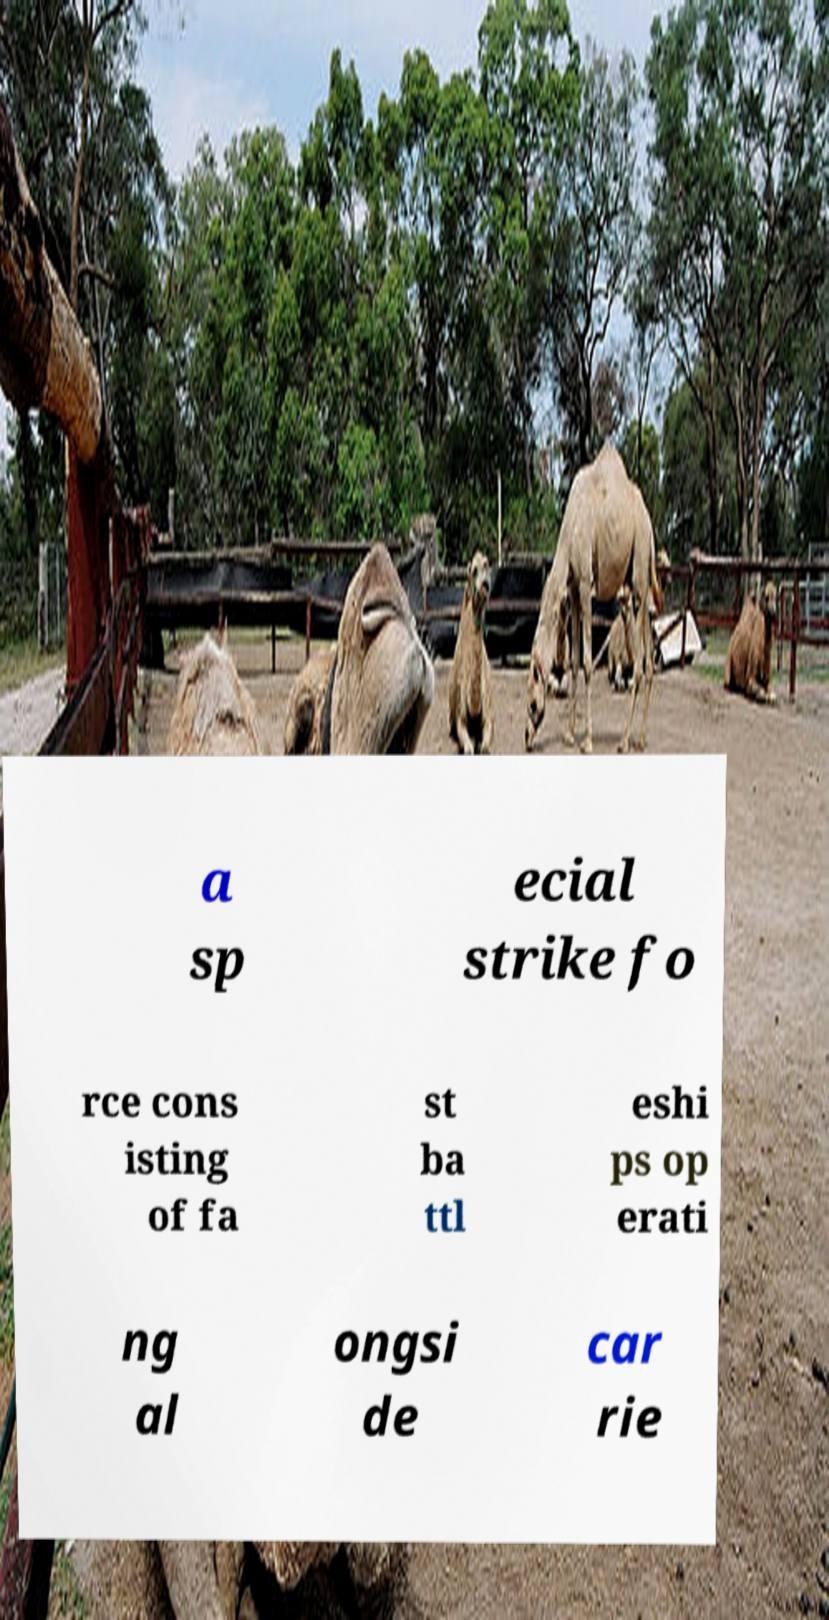For documentation purposes, I need the text within this image transcribed. Could you provide that? a sp ecial strike fo rce cons isting of fa st ba ttl eshi ps op erati ng al ongsi de car rie 